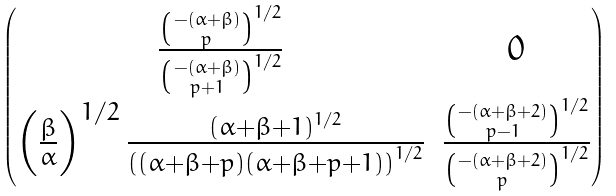Convert formula to latex. <formula><loc_0><loc_0><loc_500><loc_500>\begin{pmatrix} \frac { \binom { - ( \alpha + \beta ) } { p } ^ { 1 / 2 } } { \binom { - ( \alpha + \beta ) } { p + 1 } ^ { 1 / 2 } } & 0 \\ \left ( \frac { \beta } { \alpha } \right ) ^ { 1 / 2 } \frac { ( \alpha + \beta + 1 ) ^ { 1 / 2 } } { \left ( ( \alpha + \beta + p ) ( \alpha + \beta + p + 1 ) \right ) ^ { 1 / 2 } } & \frac { \binom { - ( \alpha + \beta + 2 ) } { p - 1 } ^ { 1 / 2 } } { \binom { - ( \alpha + \beta + 2 ) } { p } ^ { 1 / 2 } } \end{pmatrix}</formula> 